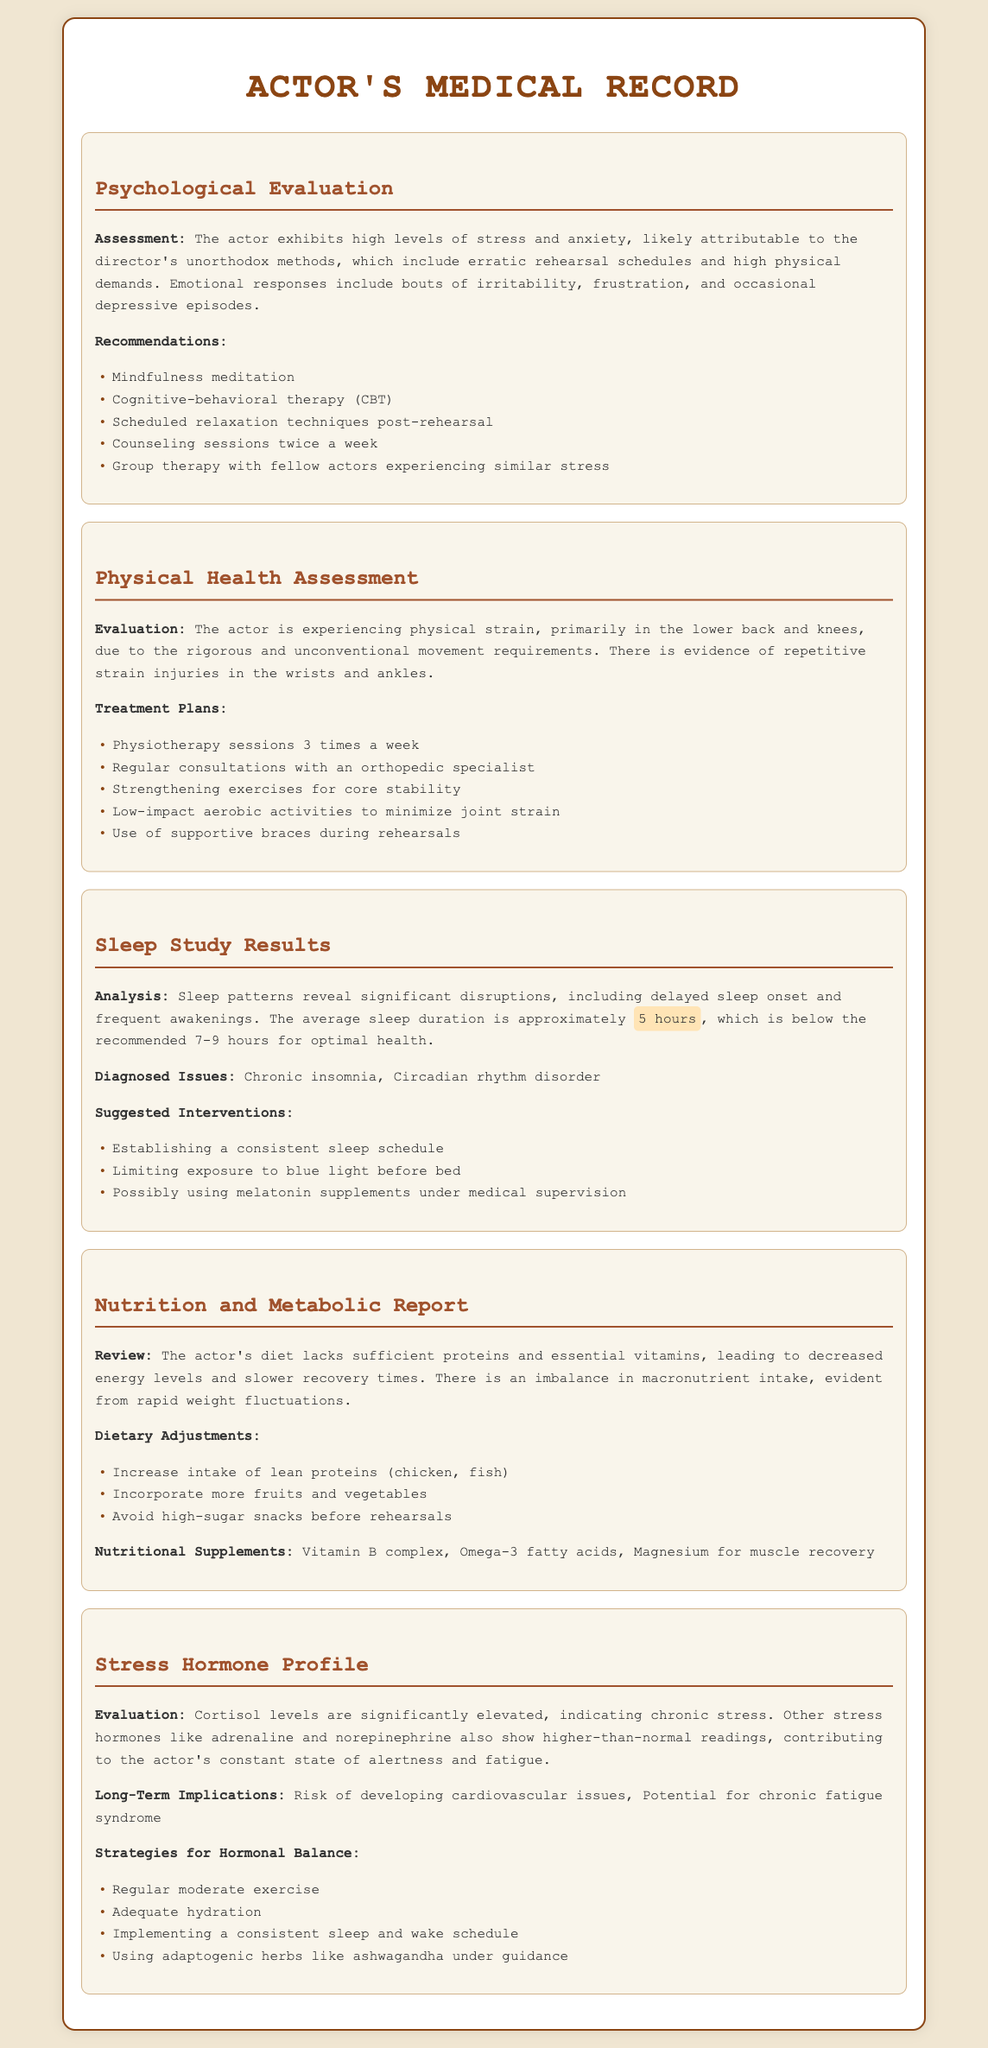What is the primary emotional response identified in the Psychological Evaluation? The document notes that the actor experiences irritability.
Answer: irritability How many physiotherapy sessions are recommended per week? The Physical Health Assessment states that physiotherapy sessions are recommended three times a week.
Answer: 3 times a week What is the average sleep duration reported in the Sleep Study Results? The Sleep Study Results indicate that the average sleep duration is approximately 5 hours, which is below the recommended amount.
Answer: 5 hours Which dietary adjustment is suggested to increase energy levels? The Nutrition and Metabolic Report recommends increasing the intake of lean proteins.
Answer: Increase intake of lean proteins What are the long-term health implications mentioned in the Stress Hormone Profile? The report highlights risks of developing cardiovascular issues and potential for chronic fatigue syndrome as long-term implications.
Answer: cardiovascular issues, chronic fatigue syndrome How frequently should counseling sessions be held according to the Psychological Evaluation? The Psychological Evaluation recommends counseling sessions twice a week.
Answer: twice a week What hormonal level is significantly elevated as mentioned in the Stress Hormone Profile? The Stress Hormone Profile indicates that cortisol levels are significantly elevated.
Answer: cortisol What is one coping strategy recommended for managing stress? The Psychological Evaluation suggests mindfulness meditation as a coping strategy.
Answer: mindfulness meditation What diagnosis is included in the Sleep Study Results? The document identifies chronic insomnia as a diagnosed issue.
Answer: chronic insomnia 